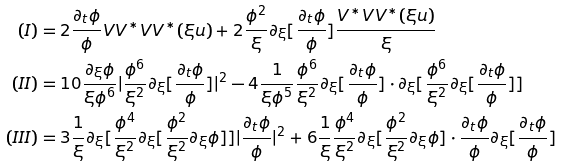<formula> <loc_0><loc_0><loc_500><loc_500>( I ) & = 2 \frac { \partial _ { t } \phi } { \phi } V V ^ { \ast } V V ^ { \ast } ( \xi u ) + 2 \frac { \phi ^ { 2 } } { \xi } \partial _ { \xi } [ \frac { \partial _ { t } \phi } { \phi } ] \frac { V ^ { \ast } V V ^ { \ast } ( \xi u ) } { \xi } \\ ( I I ) & = 1 0 \frac { \partial _ { \xi } \phi } { \xi \phi ^ { 6 } } | \frac { \phi ^ { 6 } } { \xi ^ { 2 } } \partial _ { \xi } [ \frac { \partial _ { t } \phi } { \phi } ] | ^ { 2 } - 4 \frac { 1 } { \xi \phi ^ { 5 } } \frac { \phi ^ { 6 } } { \xi ^ { 2 } } \partial _ { \xi } [ \frac { \partial _ { t } \phi } { \phi } ] \cdot \partial _ { \xi } [ \frac { \phi ^ { 6 } } { \xi ^ { 2 } } \partial _ { \xi } [ \frac { \partial _ { t } \phi } { \phi } ] ] \\ ( I I I ) & = 3 \frac { 1 } { \xi } \partial _ { \xi } [ \frac { \phi ^ { 4 } } { \xi ^ { 2 } } \partial _ { \xi } [ \frac { \phi ^ { 2 } } { \xi ^ { 2 } } \partial _ { \xi } \phi ] ] | \frac { \partial _ { t } \phi } { \phi } | ^ { 2 } + 6 \frac { 1 } { \xi } \frac { \phi ^ { 4 } } { \xi ^ { 2 } } \partial _ { \xi } [ \frac { \phi ^ { 2 } } { \xi ^ { 2 } } \partial _ { \xi } \phi ] \cdot \frac { \partial _ { t } \phi } { \phi } \partial _ { \xi } [ \frac { \partial _ { t } \phi } { \phi } ]</formula> 